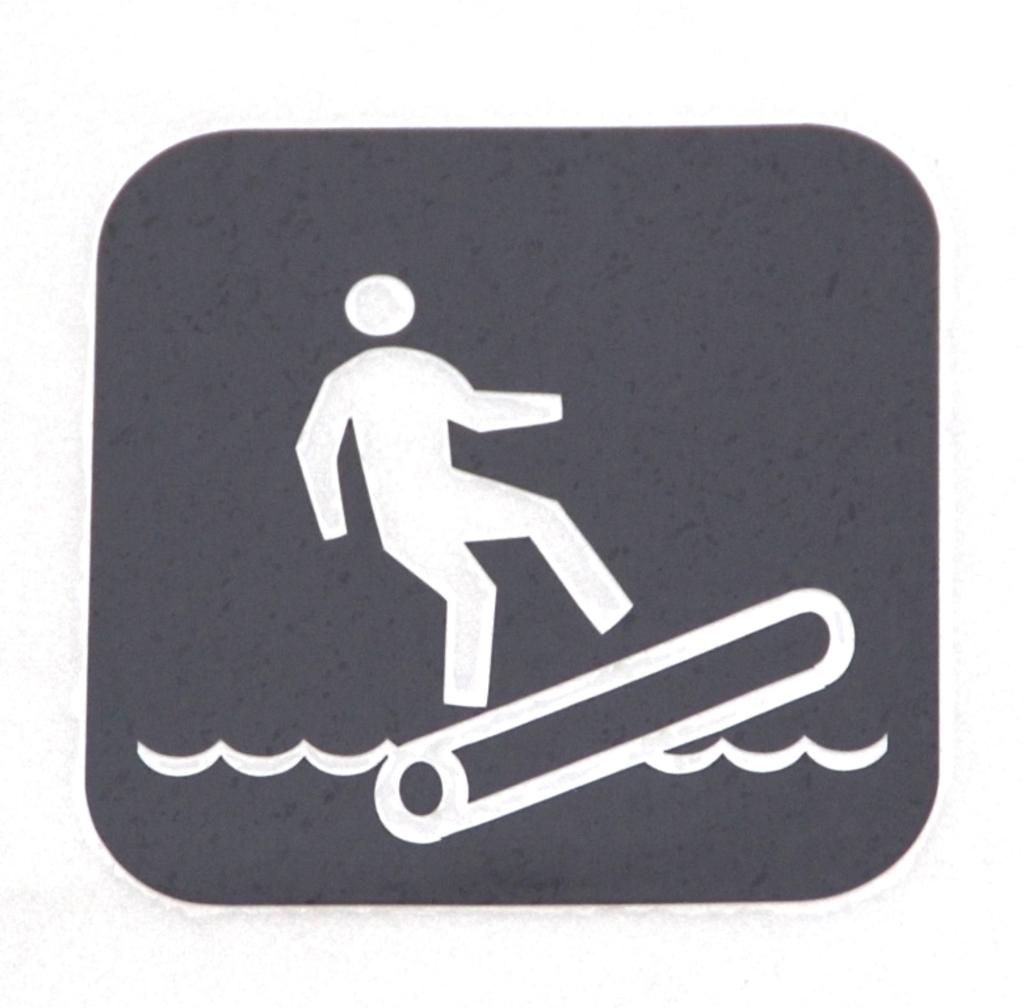What is the main subject of the image? The image contains a painting. What is the painting depicting? The painting depicts a person surfing on the water. What color is the background of the painting? The background of the painting is grey in color. What type of instrument is the person playing while surfing in the image? There is no instrument present in the image; the person is surfing on the water. Is the scene in the painting taking place during winter? The facts provided do not mention any seasonal context, so it cannot be determined if the scene is taking place during winter. 